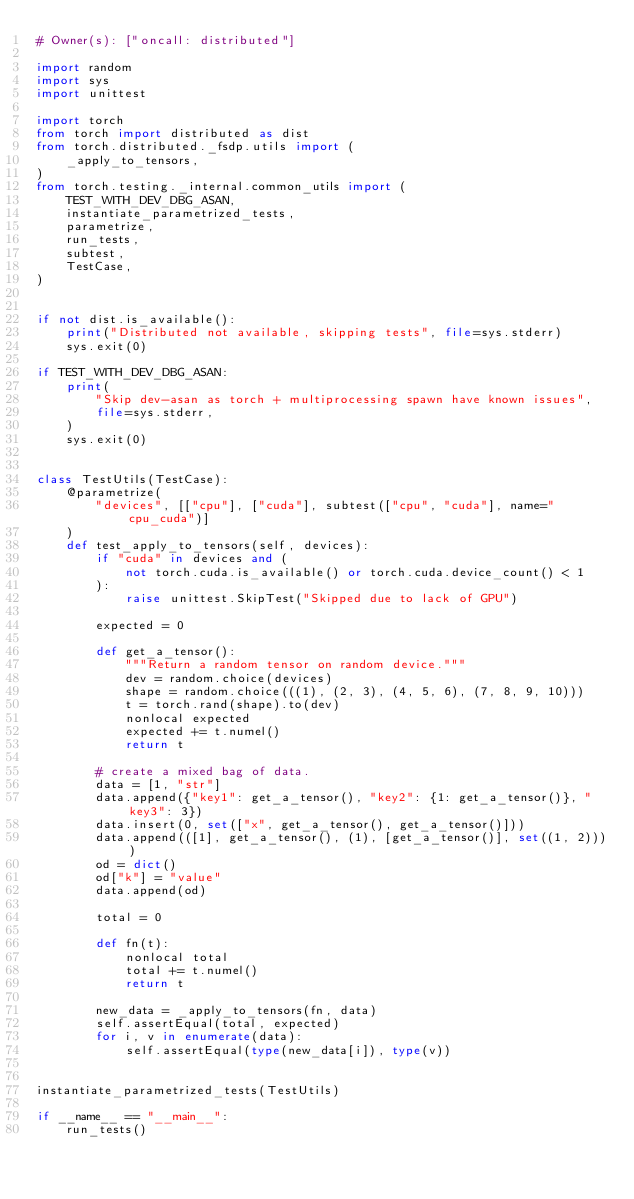Convert code to text. <code><loc_0><loc_0><loc_500><loc_500><_Python_># Owner(s): ["oncall: distributed"]

import random
import sys
import unittest

import torch
from torch import distributed as dist
from torch.distributed._fsdp.utils import (
    _apply_to_tensors,
)
from torch.testing._internal.common_utils import (
    TEST_WITH_DEV_DBG_ASAN,
    instantiate_parametrized_tests,
    parametrize,
    run_tests,
    subtest,
    TestCase,
)


if not dist.is_available():
    print("Distributed not available, skipping tests", file=sys.stderr)
    sys.exit(0)

if TEST_WITH_DEV_DBG_ASAN:
    print(
        "Skip dev-asan as torch + multiprocessing spawn have known issues",
        file=sys.stderr,
    )
    sys.exit(0)


class TestUtils(TestCase):
    @parametrize(
        "devices", [["cpu"], ["cuda"], subtest(["cpu", "cuda"], name="cpu_cuda")]
    )
    def test_apply_to_tensors(self, devices):
        if "cuda" in devices and (
            not torch.cuda.is_available() or torch.cuda.device_count() < 1
        ):
            raise unittest.SkipTest("Skipped due to lack of GPU")

        expected = 0

        def get_a_tensor():
            """Return a random tensor on random device."""
            dev = random.choice(devices)
            shape = random.choice(((1), (2, 3), (4, 5, 6), (7, 8, 9, 10)))
            t = torch.rand(shape).to(dev)
            nonlocal expected
            expected += t.numel()
            return t

        # create a mixed bag of data.
        data = [1, "str"]
        data.append({"key1": get_a_tensor(), "key2": {1: get_a_tensor()}, "key3": 3})
        data.insert(0, set(["x", get_a_tensor(), get_a_tensor()]))
        data.append(([1], get_a_tensor(), (1), [get_a_tensor()], set((1, 2))))
        od = dict()
        od["k"] = "value"
        data.append(od)

        total = 0

        def fn(t):
            nonlocal total
            total += t.numel()
            return t

        new_data = _apply_to_tensors(fn, data)
        self.assertEqual(total, expected)
        for i, v in enumerate(data):
            self.assertEqual(type(new_data[i]), type(v))


instantiate_parametrized_tests(TestUtils)

if __name__ == "__main__":
    run_tests()
</code> 